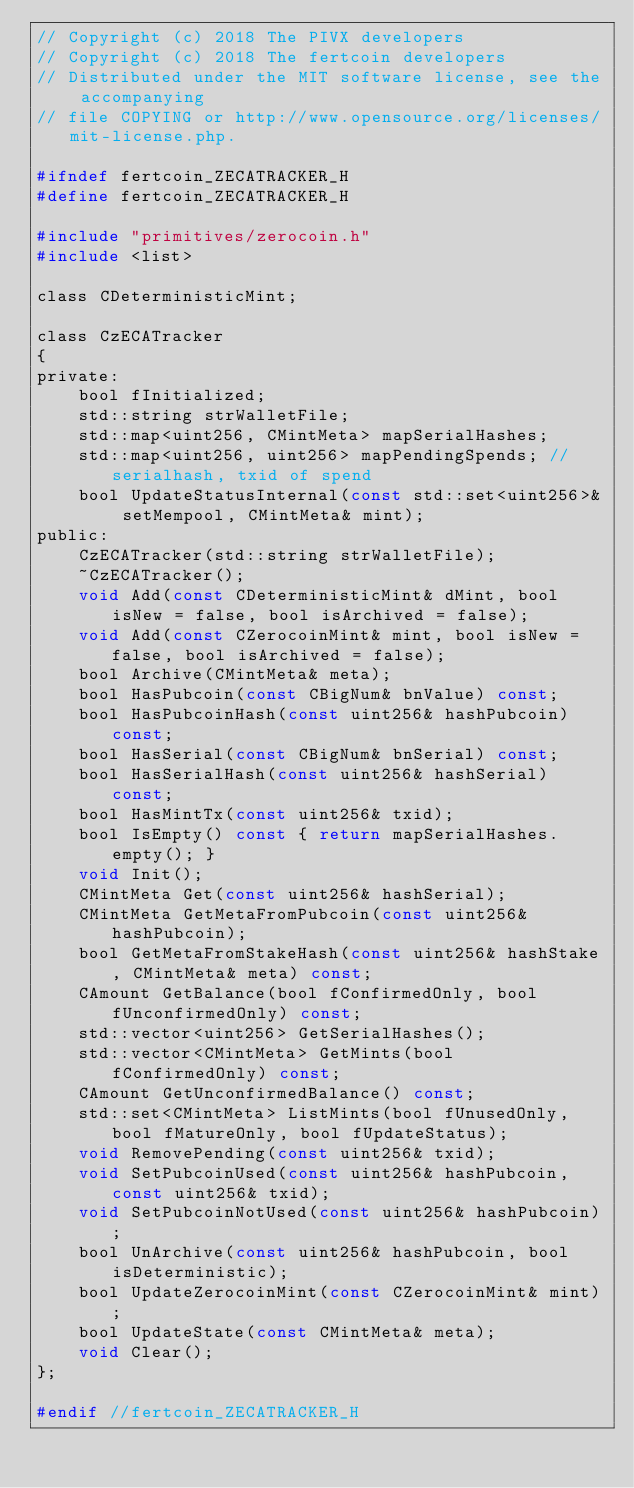Convert code to text. <code><loc_0><loc_0><loc_500><loc_500><_C_>// Copyright (c) 2018 The PIVX developers
// Copyright (c) 2018 The fertcoin developers
// Distributed under the MIT software license, see the accompanying
// file COPYING or http://www.opensource.org/licenses/mit-license.php.

#ifndef fertcoin_ZECATRACKER_H
#define fertcoin_ZECATRACKER_H

#include "primitives/zerocoin.h"
#include <list>

class CDeterministicMint;

class CzECATracker
{
private:
    bool fInitialized;
    std::string strWalletFile;
    std::map<uint256, CMintMeta> mapSerialHashes;
    std::map<uint256, uint256> mapPendingSpends; //serialhash, txid of spend
    bool UpdateStatusInternal(const std::set<uint256>& setMempool, CMintMeta& mint);
public:
    CzECATracker(std::string strWalletFile);
    ~CzECATracker();
    void Add(const CDeterministicMint& dMint, bool isNew = false, bool isArchived = false);
    void Add(const CZerocoinMint& mint, bool isNew = false, bool isArchived = false);
    bool Archive(CMintMeta& meta);
    bool HasPubcoin(const CBigNum& bnValue) const;
    bool HasPubcoinHash(const uint256& hashPubcoin) const;
    bool HasSerial(const CBigNum& bnSerial) const;
    bool HasSerialHash(const uint256& hashSerial) const;
    bool HasMintTx(const uint256& txid);
    bool IsEmpty() const { return mapSerialHashes.empty(); }
    void Init();
    CMintMeta Get(const uint256& hashSerial);
    CMintMeta GetMetaFromPubcoin(const uint256& hashPubcoin);
    bool GetMetaFromStakeHash(const uint256& hashStake, CMintMeta& meta) const;
    CAmount GetBalance(bool fConfirmedOnly, bool fUnconfirmedOnly) const;
    std::vector<uint256> GetSerialHashes();
    std::vector<CMintMeta> GetMints(bool fConfirmedOnly) const;
    CAmount GetUnconfirmedBalance() const;
    std::set<CMintMeta> ListMints(bool fUnusedOnly, bool fMatureOnly, bool fUpdateStatus);
    void RemovePending(const uint256& txid);
    void SetPubcoinUsed(const uint256& hashPubcoin, const uint256& txid);
    void SetPubcoinNotUsed(const uint256& hashPubcoin);
    bool UnArchive(const uint256& hashPubcoin, bool isDeterministic);
    bool UpdateZerocoinMint(const CZerocoinMint& mint);
    bool UpdateState(const CMintMeta& meta);
    void Clear();
};

#endif //fertcoin_ZECATRACKER_H
</code> 